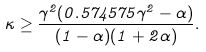<formula> <loc_0><loc_0><loc_500><loc_500>\kappa \geq \frac { \gamma ^ { 2 } ( 0 . 5 7 4 5 7 5 \gamma ^ { 2 } - \alpha ) } { ( 1 - \alpha ) ( 1 + 2 \alpha ) } .</formula> 